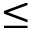Convert formula to latex. <formula><loc_0><loc_0><loc_500><loc_500>\leq</formula> 